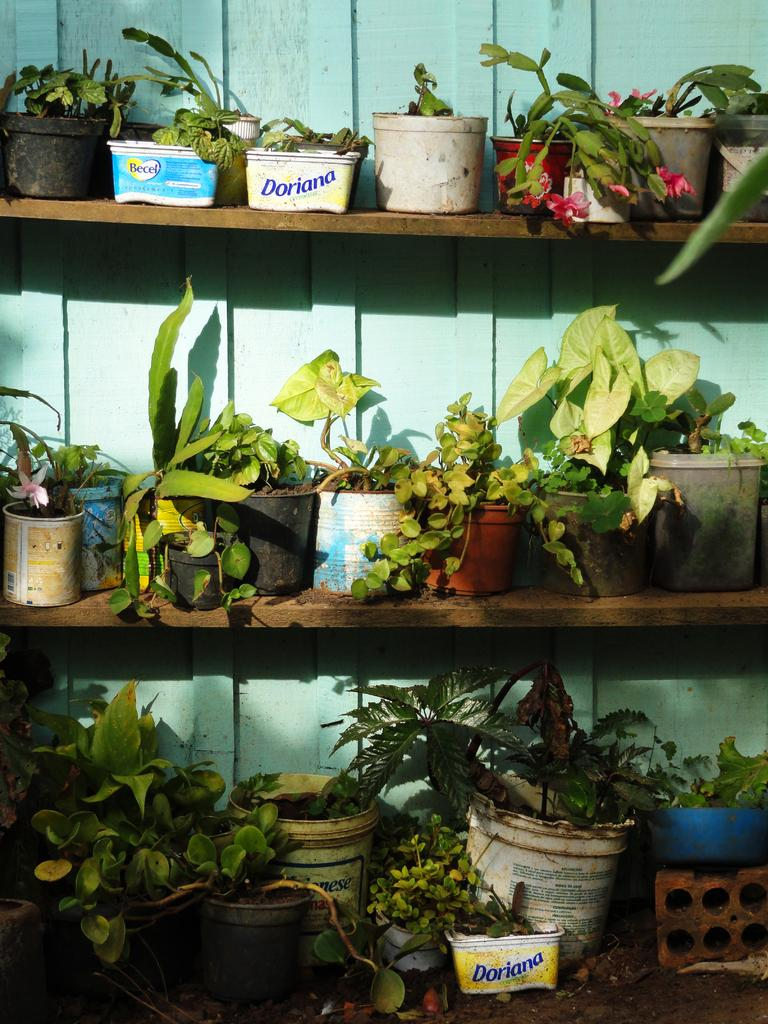What type of furniture is present in the image? There are shelves in the image. What can be found on the shelves? There are flower pots on the shelves. What is the background of the image? There is a wall visible in the image. What is the price of the van parked next to the shelves in the image? There is no van present in the image, so it is not possible to determine the price. 